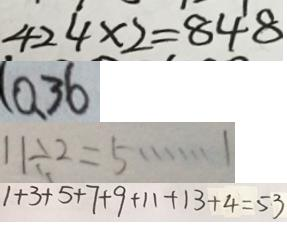<formula> <loc_0><loc_0><loc_500><loc_500>4 2 4 \times 2 = 8 4 8 
 ( 0 、 3 6 
 1 1 \div 2 = 5 \cdots 1 
 1 + 3 + 5 + 7 + 9 + 1 1 + 1 3 + 4 = 5 3</formula> 